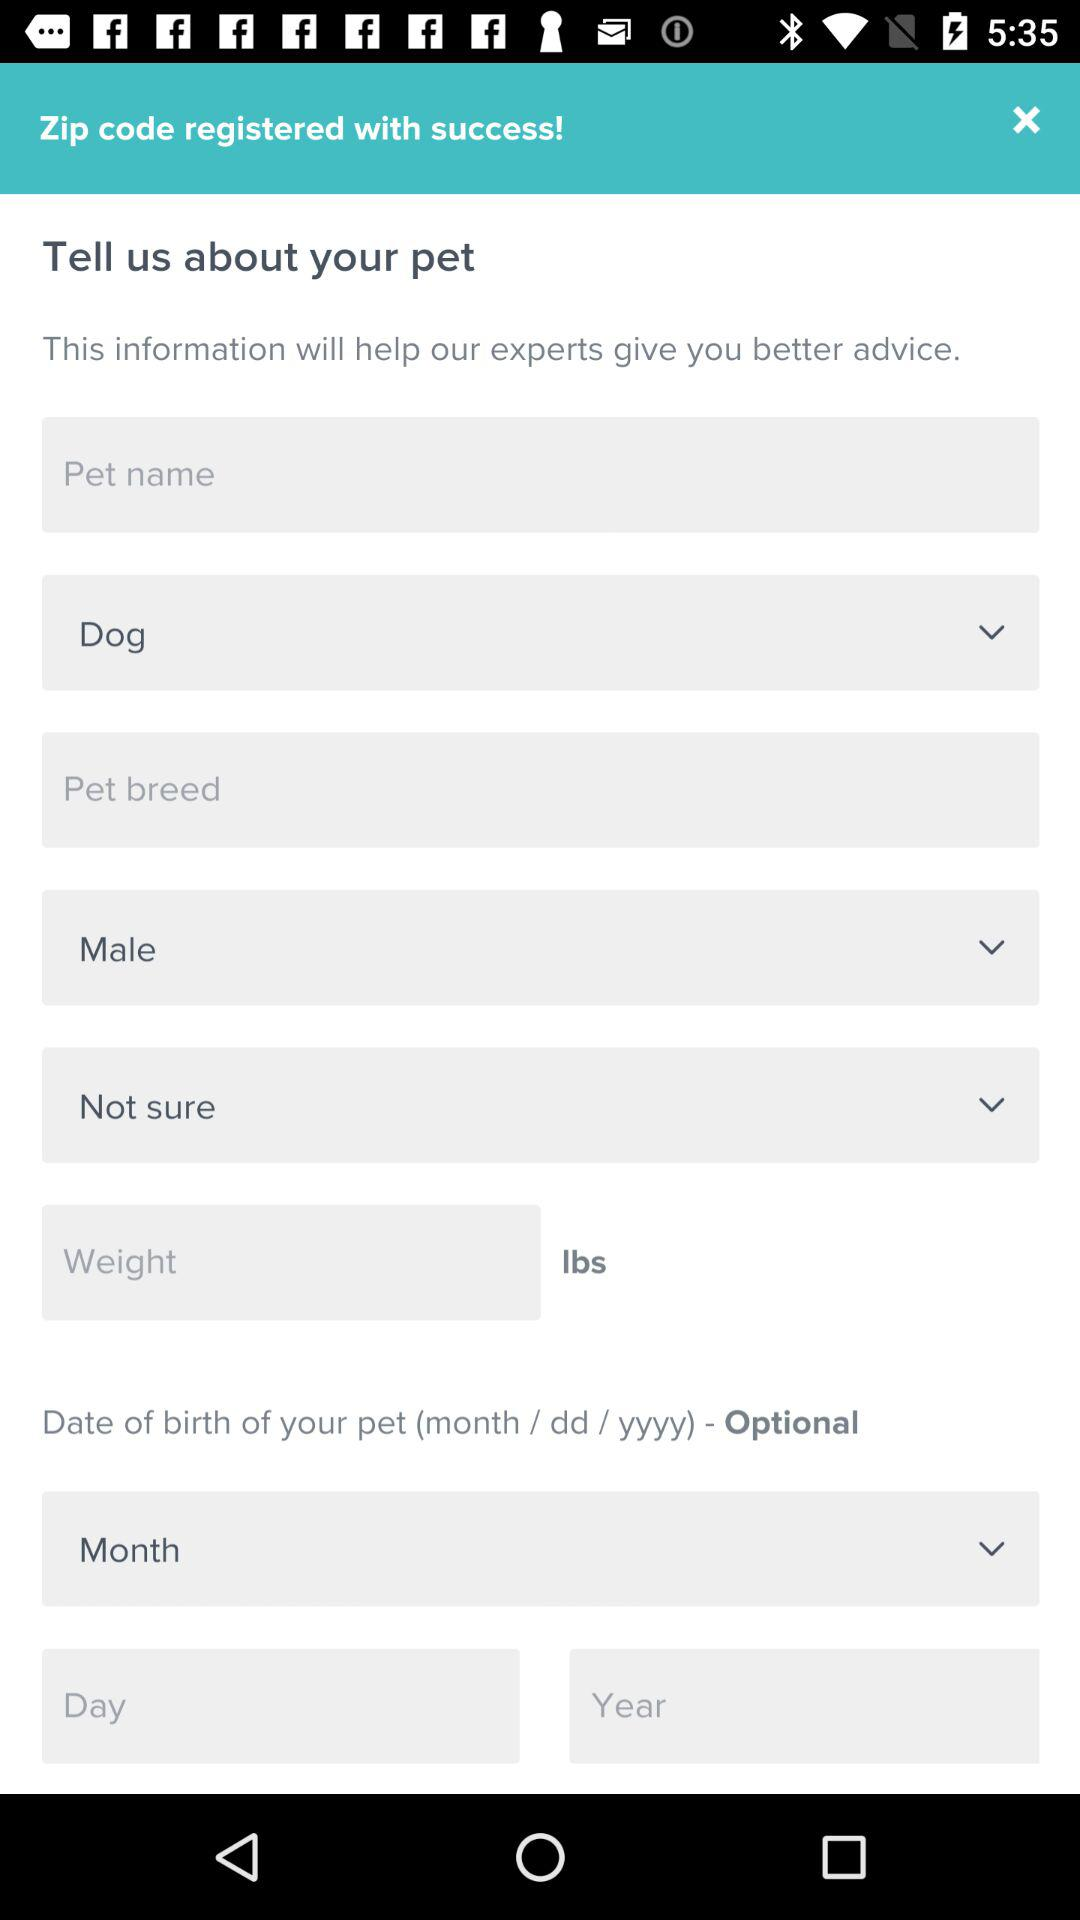What is the unit of weight? The unit of weight is "lbs". 